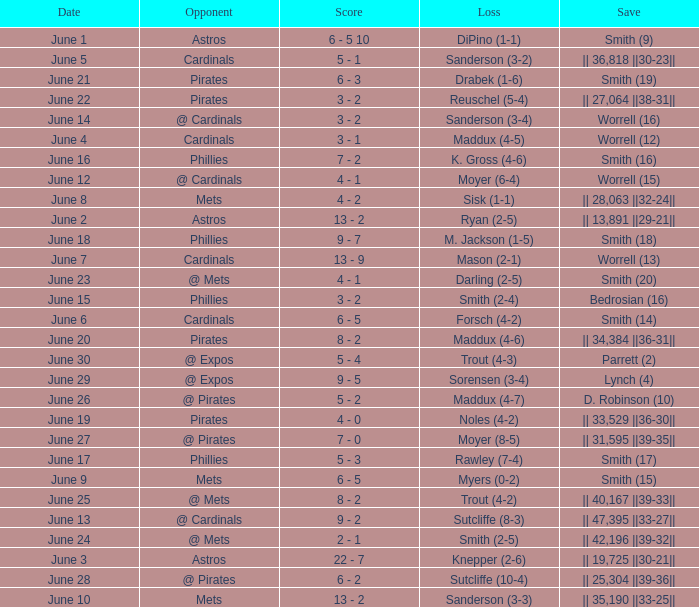On which day did the Chicago Cubs have a loss of trout (4-2)? June 25. 